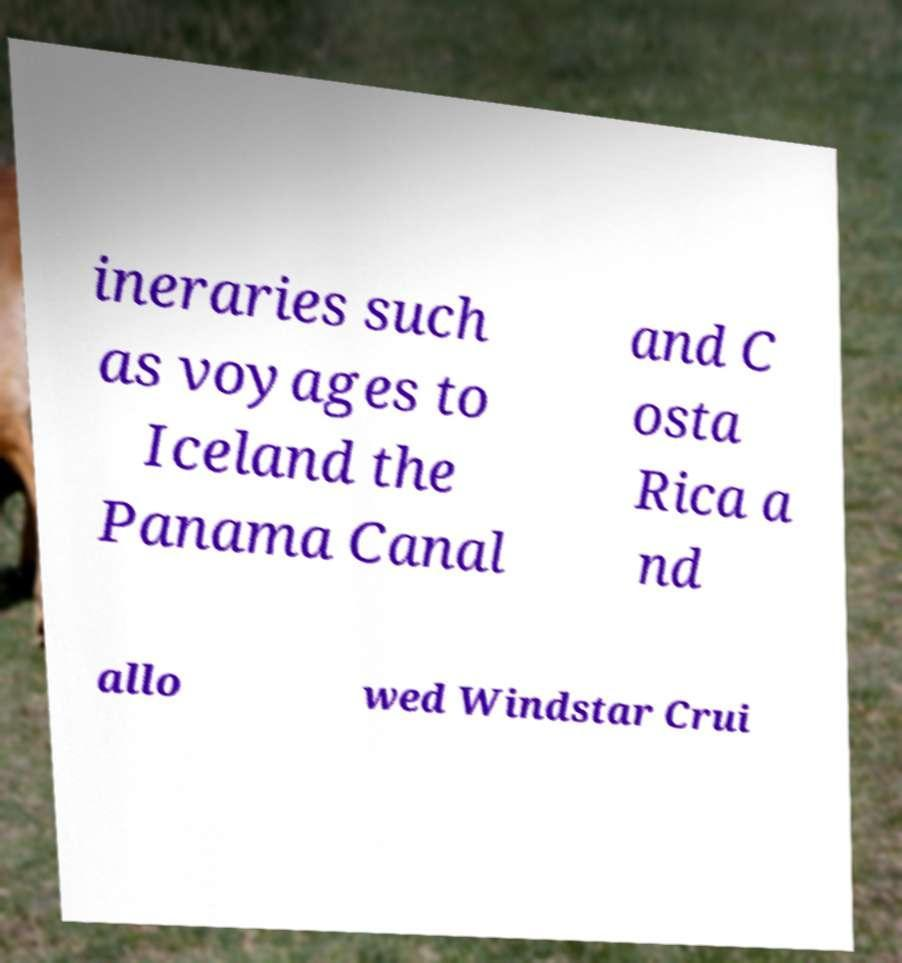For documentation purposes, I need the text within this image transcribed. Could you provide that? ineraries such as voyages to Iceland the Panama Canal and C osta Rica a nd allo wed Windstar Crui 